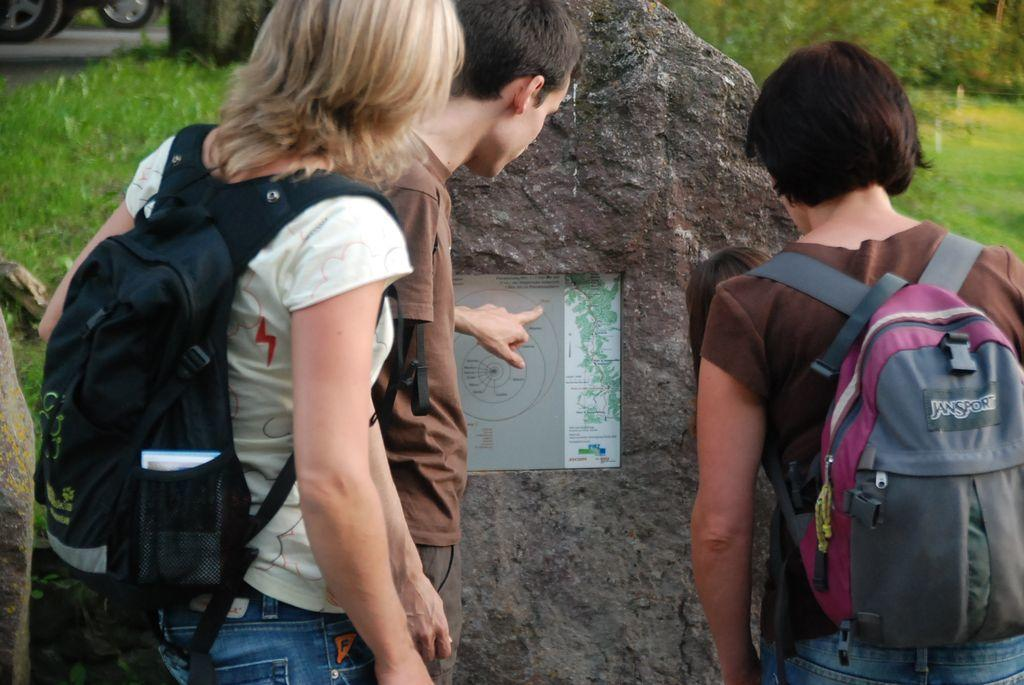Provide a one-sentence caption for the provided image. Three young backpackers, one with a JanSport backpack, looking at a map on the side of a rock. 